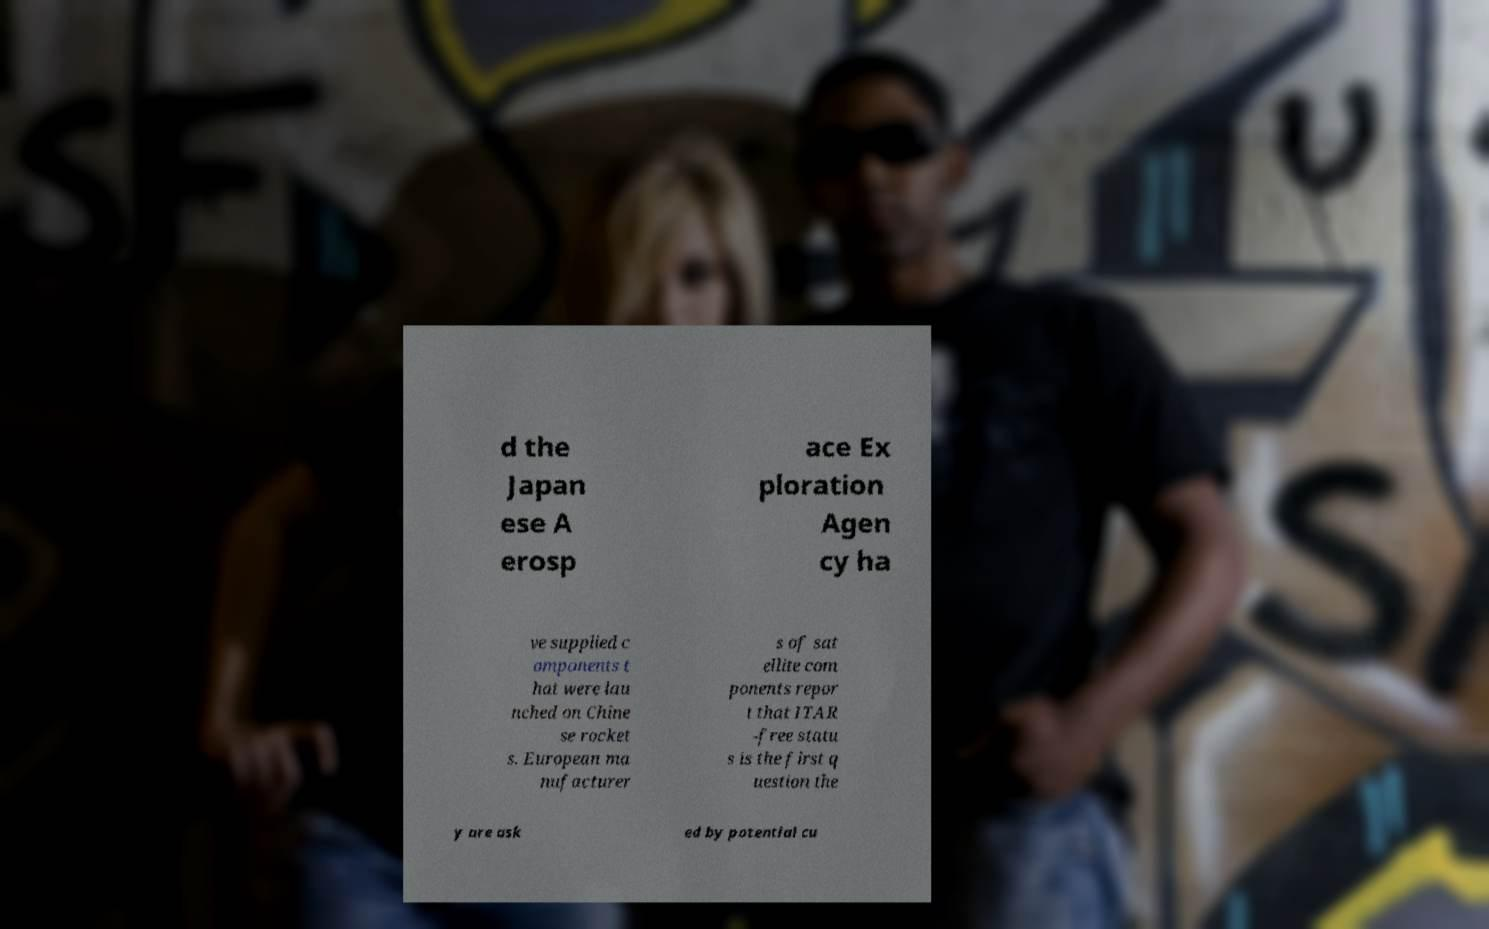There's text embedded in this image that I need extracted. Can you transcribe it verbatim? d the Japan ese A erosp ace Ex ploration Agen cy ha ve supplied c omponents t hat were lau nched on Chine se rocket s. European ma nufacturer s of sat ellite com ponents repor t that ITAR -free statu s is the first q uestion the y are ask ed by potential cu 